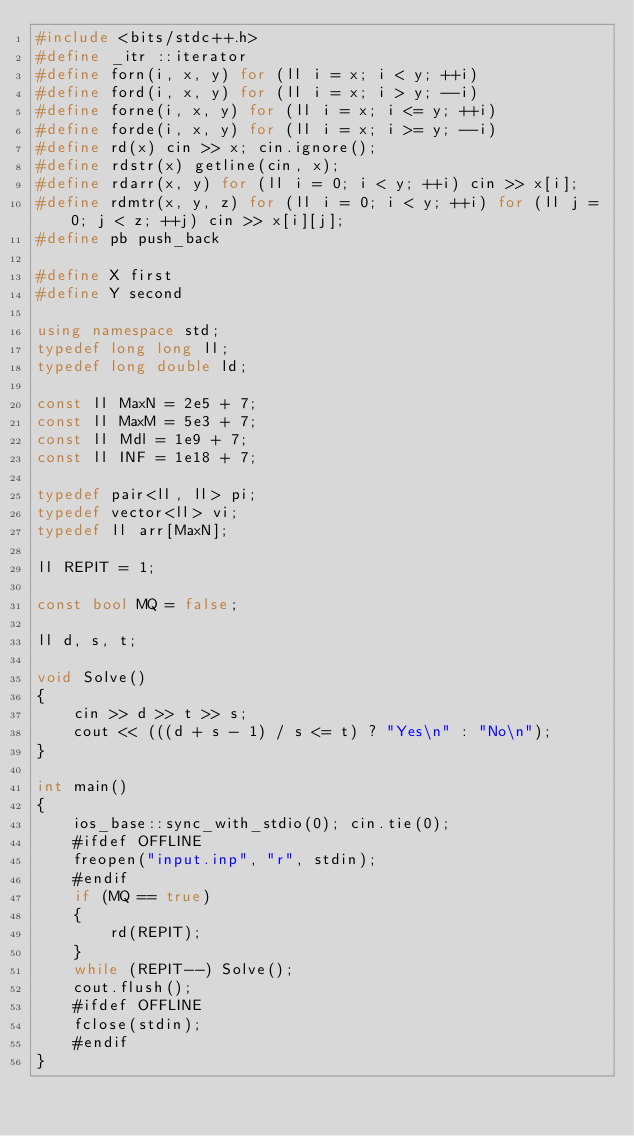<code> <loc_0><loc_0><loc_500><loc_500><_C++_>#include <bits/stdc++.h>
#define _itr ::iterator
#define forn(i, x, y) for (ll i = x; i < y; ++i)
#define ford(i, x, y) for (ll i = x; i > y; --i)
#define forne(i, x, y) for (ll i = x; i <= y; ++i)
#define forde(i, x, y) for (ll i = x; i >= y; --i)
#define rd(x) cin >> x; cin.ignore();
#define rdstr(x) getline(cin, x);
#define rdarr(x, y) for (ll i = 0; i < y; ++i) cin >> x[i];
#define rdmtr(x, y, z) for (ll i = 0; i < y; ++i) for (ll j = 0; j < z; ++j) cin >> x[i][j];
#define pb push_back

#define X first
#define Y second

using namespace std;
typedef long long ll;
typedef long double ld;

const ll MaxN = 2e5 + 7;
const ll MaxM = 5e3 + 7;
const ll Mdl = 1e9 + 7;
const ll INF = 1e18 + 7;

typedef pair<ll, ll> pi;
typedef vector<ll> vi;
typedef ll arr[MaxN];

ll REPIT = 1;

const bool MQ = false;

ll d, s, t;

void Solve()
{
    cin >> d >> t >> s;
    cout << (((d + s - 1) / s <= t) ? "Yes\n" : "No\n");
}

int main()
{
    ios_base::sync_with_stdio(0); cin.tie(0);
    #ifdef OFFLINE
    freopen("input.inp", "r", stdin);
    #endif
    if (MQ == true)
    {
        rd(REPIT);
    }
    while (REPIT--) Solve();
    cout.flush();
    #ifdef OFFLINE
    fclose(stdin);
    #endif
}
</code> 